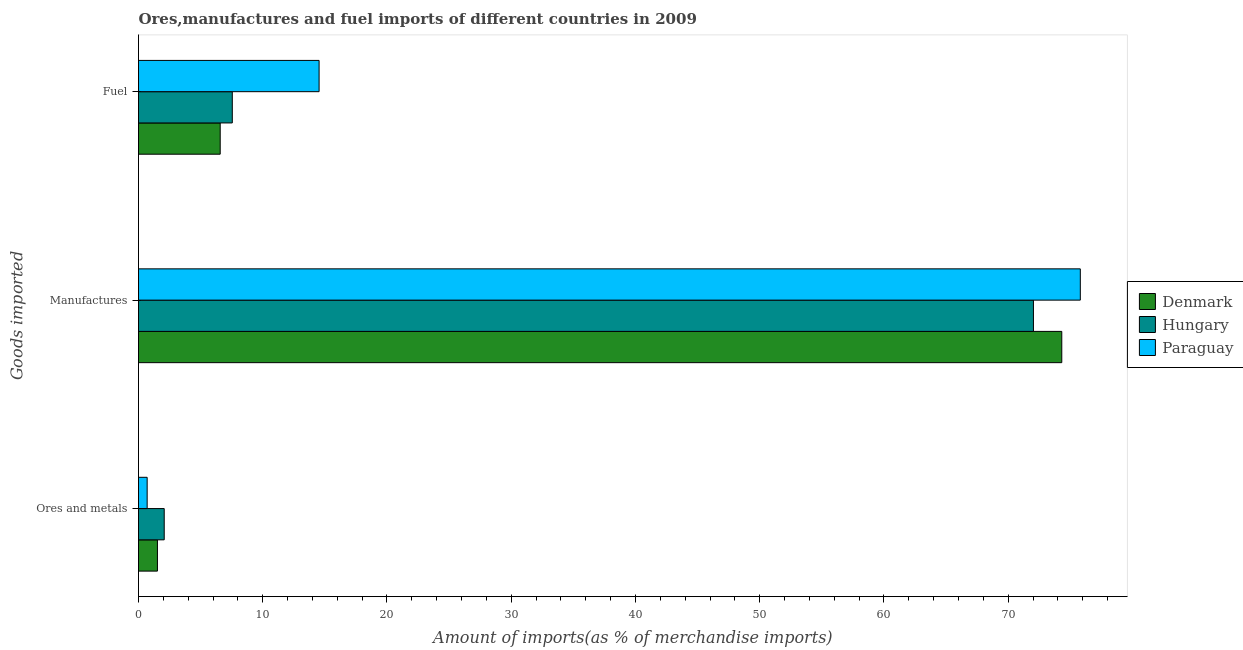How many different coloured bars are there?
Give a very brief answer. 3. Are the number of bars per tick equal to the number of legend labels?
Give a very brief answer. Yes. What is the label of the 1st group of bars from the top?
Ensure brevity in your answer.  Fuel. What is the percentage of ores and metals imports in Denmark?
Your response must be concise. 1.52. Across all countries, what is the maximum percentage of manufactures imports?
Offer a very short reply. 75.81. Across all countries, what is the minimum percentage of ores and metals imports?
Provide a short and direct response. 0.7. In which country was the percentage of manufactures imports maximum?
Offer a terse response. Paraguay. In which country was the percentage of ores and metals imports minimum?
Provide a succinct answer. Paraguay. What is the total percentage of ores and metals imports in the graph?
Your answer should be very brief. 4.29. What is the difference between the percentage of ores and metals imports in Paraguay and that in Denmark?
Provide a short and direct response. -0.83. What is the difference between the percentage of manufactures imports in Paraguay and the percentage of ores and metals imports in Denmark?
Offer a very short reply. 74.28. What is the average percentage of manufactures imports per country?
Offer a very short reply. 74.05. What is the difference between the percentage of manufactures imports and percentage of ores and metals imports in Denmark?
Your answer should be very brief. 72.79. What is the ratio of the percentage of ores and metals imports in Denmark to that in Paraguay?
Offer a terse response. 2.19. Is the percentage of fuel imports in Hungary less than that in Denmark?
Your response must be concise. No. Is the difference between the percentage of manufactures imports in Denmark and Hungary greater than the difference between the percentage of ores and metals imports in Denmark and Hungary?
Your answer should be compact. Yes. What is the difference between the highest and the second highest percentage of fuel imports?
Ensure brevity in your answer.  6.99. What is the difference between the highest and the lowest percentage of manufactures imports?
Make the answer very short. 3.77. Is the sum of the percentage of fuel imports in Paraguay and Hungary greater than the maximum percentage of ores and metals imports across all countries?
Your answer should be very brief. Yes. What does the 1st bar from the bottom in Ores and metals represents?
Offer a very short reply. Denmark. Is it the case that in every country, the sum of the percentage of ores and metals imports and percentage of manufactures imports is greater than the percentage of fuel imports?
Your answer should be compact. Yes. How many countries are there in the graph?
Offer a very short reply. 3. What is the difference between two consecutive major ticks on the X-axis?
Your answer should be very brief. 10. Does the graph contain grids?
Your answer should be compact. No. How many legend labels are there?
Offer a very short reply. 3. What is the title of the graph?
Offer a very short reply. Ores,manufactures and fuel imports of different countries in 2009. Does "Oman" appear as one of the legend labels in the graph?
Ensure brevity in your answer.  No. What is the label or title of the X-axis?
Provide a succinct answer. Amount of imports(as % of merchandise imports). What is the label or title of the Y-axis?
Make the answer very short. Goods imported. What is the Amount of imports(as % of merchandise imports) in Denmark in Ores and metals?
Offer a terse response. 1.52. What is the Amount of imports(as % of merchandise imports) in Hungary in Ores and metals?
Your response must be concise. 2.07. What is the Amount of imports(as % of merchandise imports) of Paraguay in Ores and metals?
Keep it short and to the point. 0.7. What is the Amount of imports(as % of merchandise imports) in Denmark in Manufactures?
Keep it short and to the point. 74.32. What is the Amount of imports(as % of merchandise imports) in Hungary in Manufactures?
Keep it short and to the point. 72.04. What is the Amount of imports(as % of merchandise imports) in Paraguay in Manufactures?
Provide a succinct answer. 75.81. What is the Amount of imports(as % of merchandise imports) in Denmark in Fuel?
Your answer should be compact. 6.58. What is the Amount of imports(as % of merchandise imports) in Hungary in Fuel?
Offer a terse response. 7.55. What is the Amount of imports(as % of merchandise imports) in Paraguay in Fuel?
Your response must be concise. 14.54. Across all Goods imported, what is the maximum Amount of imports(as % of merchandise imports) in Denmark?
Provide a succinct answer. 74.32. Across all Goods imported, what is the maximum Amount of imports(as % of merchandise imports) in Hungary?
Your answer should be compact. 72.04. Across all Goods imported, what is the maximum Amount of imports(as % of merchandise imports) in Paraguay?
Ensure brevity in your answer.  75.81. Across all Goods imported, what is the minimum Amount of imports(as % of merchandise imports) in Denmark?
Your response must be concise. 1.52. Across all Goods imported, what is the minimum Amount of imports(as % of merchandise imports) in Hungary?
Your response must be concise. 2.07. Across all Goods imported, what is the minimum Amount of imports(as % of merchandise imports) of Paraguay?
Offer a very short reply. 0.7. What is the total Amount of imports(as % of merchandise imports) of Denmark in the graph?
Your response must be concise. 82.42. What is the total Amount of imports(as % of merchandise imports) of Hungary in the graph?
Ensure brevity in your answer.  81.65. What is the total Amount of imports(as % of merchandise imports) of Paraguay in the graph?
Offer a terse response. 91.04. What is the difference between the Amount of imports(as % of merchandise imports) in Denmark in Ores and metals and that in Manufactures?
Your answer should be compact. -72.79. What is the difference between the Amount of imports(as % of merchandise imports) of Hungary in Ores and metals and that in Manufactures?
Make the answer very short. -69.97. What is the difference between the Amount of imports(as % of merchandise imports) in Paraguay in Ores and metals and that in Manufactures?
Ensure brevity in your answer.  -75.11. What is the difference between the Amount of imports(as % of merchandise imports) in Denmark in Ores and metals and that in Fuel?
Your response must be concise. -5.05. What is the difference between the Amount of imports(as % of merchandise imports) in Hungary in Ores and metals and that in Fuel?
Offer a terse response. -5.48. What is the difference between the Amount of imports(as % of merchandise imports) of Paraguay in Ores and metals and that in Fuel?
Keep it short and to the point. -13.84. What is the difference between the Amount of imports(as % of merchandise imports) in Denmark in Manufactures and that in Fuel?
Provide a short and direct response. 67.74. What is the difference between the Amount of imports(as % of merchandise imports) in Hungary in Manufactures and that in Fuel?
Offer a terse response. 64.49. What is the difference between the Amount of imports(as % of merchandise imports) of Paraguay in Manufactures and that in Fuel?
Provide a short and direct response. 61.27. What is the difference between the Amount of imports(as % of merchandise imports) of Denmark in Ores and metals and the Amount of imports(as % of merchandise imports) of Hungary in Manufactures?
Keep it short and to the point. -70.51. What is the difference between the Amount of imports(as % of merchandise imports) in Denmark in Ores and metals and the Amount of imports(as % of merchandise imports) in Paraguay in Manufactures?
Provide a succinct answer. -74.28. What is the difference between the Amount of imports(as % of merchandise imports) in Hungary in Ores and metals and the Amount of imports(as % of merchandise imports) in Paraguay in Manufactures?
Your answer should be compact. -73.74. What is the difference between the Amount of imports(as % of merchandise imports) of Denmark in Ores and metals and the Amount of imports(as % of merchandise imports) of Hungary in Fuel?
Provide a short and direct response. -6.03. What is the difference between the Amount of imports(as % of merchandise imports) of Denmark in Ores and metals and the Amount of imports(as % of merchandise imports) of Paraguay in Fuel?
Keep it short and to the point. -13.01. What is the difference between the Amount of imports(as % of merchandise imports) of Hungary in Ores and metals and the Amount of imports(as % of merchandise imports) of Paraguay in Fuel?
Offer a very short reply. -12.47. What is the difference between the Amount of imports(as % of merchandise imports) in Denmark in Manufactures and the Amount of imports(as % of merchandise imports) in Hungary in Fuel?
Make the answer very short. 66.77. What is the difference between the Amount of imports(as % of merchandise imports) of Denmark in Manufactures and the Amount of imports(as % of merchandise imports) of Paraguay in Fuel?
Keep it short and to the point. 59.78. What is the difference between the Amount of imports(as % of merchandise imports) of Hungary in Manufactures and the Amount of imports(as % of merchandise imports) of Paraguay in Fuel?
Give a very brief answer. 57.5. What is the average Amount of imports(as % of merchandise imports) in Denmark per Goods imported?
Offer a terse response. 27.47. What is the average Amount of imports(as % of merchandise imports) in Hungary per Goods imported?
Keep it short and to the point. 27.22. What is the average Amount of imports(as % of merchandise imports) in Paraguay per Goods imported?
Ensure brevity in your answer.  30.35. What is the difference between the Amount of imports(as % of merchandise imports) of Denmark and Amount of imports(as % of merchandise imports) of Hungary in Ores and metals?
Your response must be concise. -0.55. What is the difference between the Amount of imports(as % of merchandise imports) in Denmark and Amount of imports(as % of merchandise imports) in Paraguay in Ores and metals?
Your answer should be compact. 0.83. What is the difference between the Amount of imports(as % of merchandise imports) in Hungary and Amount of imports(as % of merchandise imports) in Paraguay in Ores and metals?
Your answer should be compact. 1.37. What is the difference between the Amount of imports(as % of merchandise imports) in Denmark and Amount of imports(as % of merchandise imports) in Hungary in Manufactures?
Your answer should be compact. 2.28. What is the difference between the Amount of imports(as % of merchandise imports) of Denmark and Amount of imports(as % of merchandise imports) of Paraguay in Manufactures?
Provide a succinct answer. -1.49. What is the difference between the Amount of imports(as % of merchandise imports) of Hungary and Amount of imports(as % of merchandise imports) of Paraguay in Manufactures?
Provide a succinct answer. -3.77. What is the difference between the Amount of imports(as % of merchandise imports) of Denmark and Amount of imports(as % of merchandise imports) of Hungary in Fuel?
Offer a very short reply. -0.97. What is the difference between the Amount of imports(as % of merchandise imports) in Denmark and Amount of imports(as % of merchandise imports) in Paraguay in Fuel?
Provide a short and direct response. -7.96. What is the difference between the Amount of imports(as % of merchandise imports) in Hungary and Amount of imports(as % of merchandise imports) in Paraguay in Fuel?
Your answer should be compact. -6.99. What is the ratio of the Amount of imports(as % of merchandise imports) in Denmark in Ores and metals to that in Manufactures?
Provide a short and direct response. 0.02. What is the ratio of the Amount of imports(as % of merchandise imports) of Hungary in Ores and metals to that in Manufactures?
Give a very brief answer. 0.03. What is the ratio of the Amount of imports(as % of merchandise imports) of Paraguay in Ores and metals to that in Manufactures?
Offer a terse response. 0.01. What is the ratio of the Amount of imports(as % of merchandise imports) in Denmark in Ores and metals to that in Fuel?
Offer a very short reply. 0.23. What is the ratio of the Amount of imports(as % of merchandise imports) in Hungary in Ores and metals to that in Fuel?
Offer a terse response. 0.27. What is the ratio of the Amount of imports(as % of merchandise imports) of Paraguay in Ores and metals to that in Fuel?
Provide a succinct answer. 0.05. What is the ratio of the Amount of imports(as % of merchandise imports) of Denmark in Manufactures to that in Fuel?
Ensure brevity in your answer.  11.3. What is the ratio of the Amount of imports(as % of merchandise imports) of Hungary in Manufactures to that in Fuel?
Keep it short and to the point. 9.54. What is the ratio of the Amount of imports(as % of merchandise imports) in Paraguay in Manufactures to that in Fuel?
Your answer should be compact. 5.22. What is the difference between the highest and the second highest Amount of imports(as % of merchandise imports) of Denmark?
Your answer should be compact. 67.74. What is the difference between the highest and the second highest Amount of imports(as % of merchandise imports) of Hungary?
Make the answer very short. 64.49. What is the difference between the highest and the second highest Amount of imports(as % of merchandise imports) in Paraguay?
Make the answer very short. 61.27. What is the difference between the highest and the lowest Amount of imports(as % of merchandise imports) of Denmark?
Offer a terse response. 72.79. What is the difference between the highest and the lowest Amount of imports(as % of merchandise imports) of Hungary?
Offer a very short reply. 69.97. What is the difference between the highest and the lowest Amount of imports(as % of merchandise imports) in Paraguay?
Your answer should be compact. 75.11. 